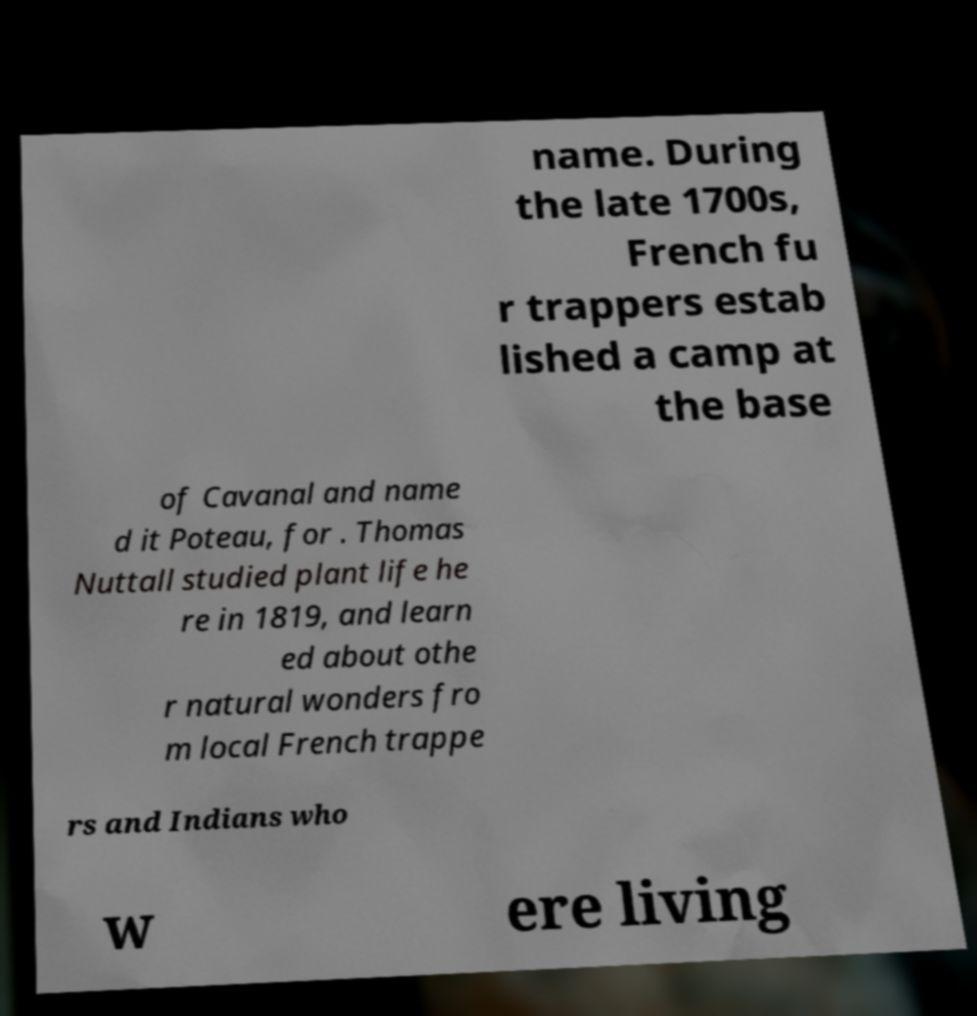Could you assist in decoding the text presented in this image and type it out clearly? name. During the late 1700s, French fu r trappers estab lished a camp at the base of Cavanal and name d it Poteau, for . Thomas Nuttall studied plant life he re in 1819, and learn ed about othe r natural wonders fro m local French trappe rs and Indians who w ere living 